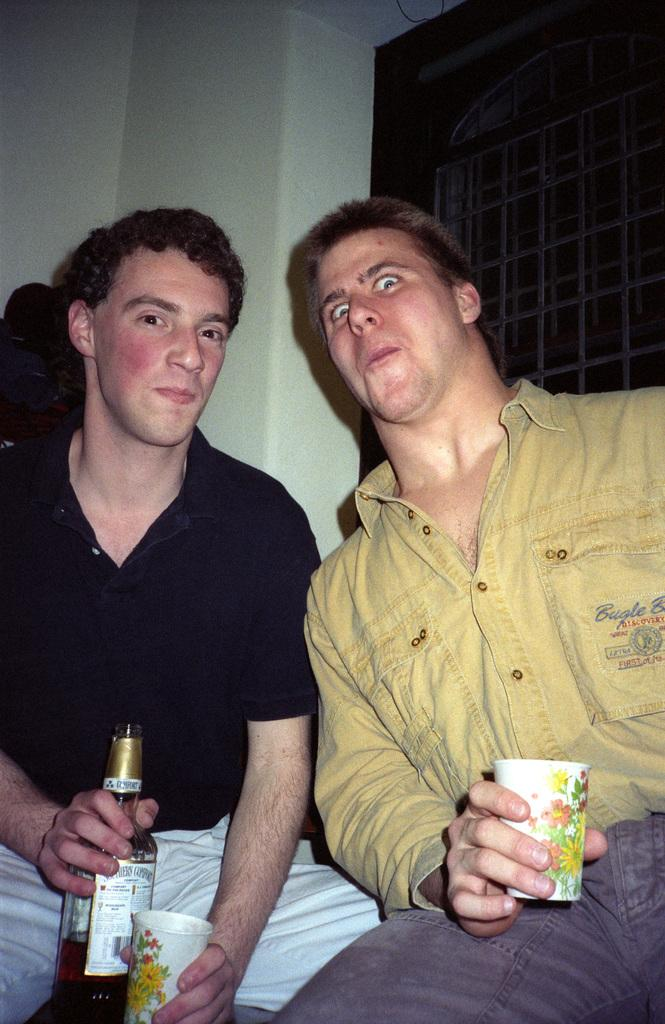How many people are in the image? There are two men in the image. What are the men doing in the image? The men are sitting. What objects are the men holding? One man is holding a bottle, and the other man is holding a glass. What can be seen in the background of the image? There is a window and a wall in the background of the image. What type of chain is hanging from the ceiling in the image? There is no chain hanging from the ceiling in the image. 